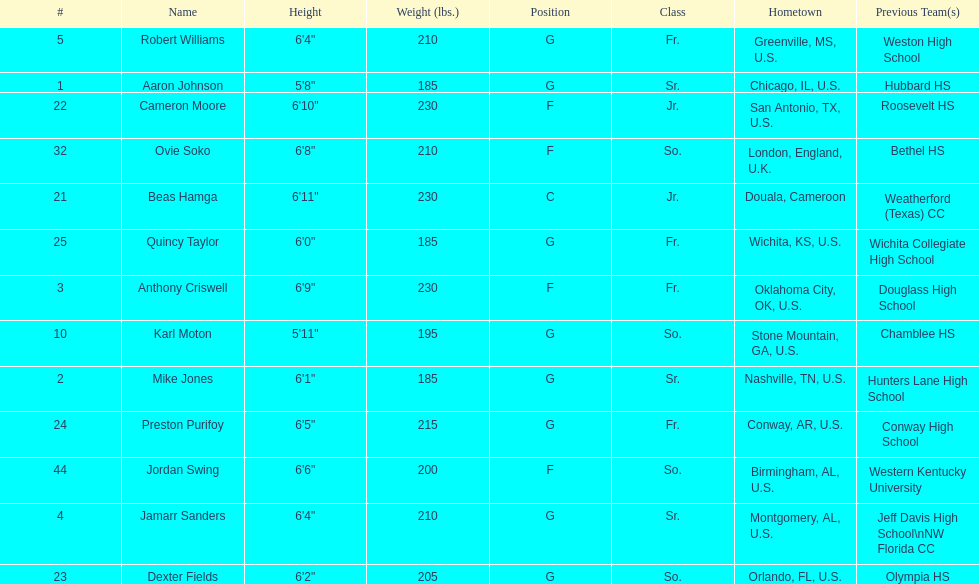How many players come from alabama? 2. 